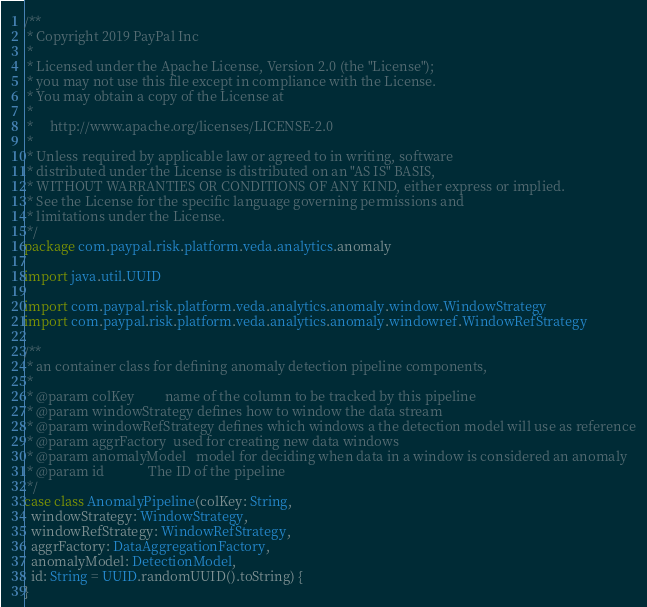Convert code to text. <code><loc_0><loc_0><loc_500><loc_500><_Scala_>/**
 * Copyright 2019 PayPal Inc
 *
 * Licensed under the Apache License, Version 2.0 (the "License");
 * you may not use this file except in compliance with the License.
 * You may obtain a copy of the License at
 *
 *     http://www.apache.org/licenses/LICENSE-2.0
 *
 * Unless required by applicable law or agreed to in writing, software
 * distributed under the License is distributed on an "AS IS" BASIS,
 * WITHOUT WARRANTIES OR CONDITIONS OF ANY KIND, either express or implied.
 * See the License for the specific language governing permissions and
 * limitations under the License.
 */
package com.paypal.risk.platform.veda.analytics.anomaly

import java.util.UUID

import com.paypal.risk.platform.veda.analytics.anomaly.window.WindowStrategy
import com.paypal.risk.platform.veda.analytics.anomaly.windowref.WindowRefStrategy

/**
 * an container class for defining anomaly detection pipeline components,
 *
 * @param colKey         name of the column to be tracked by this pipeline
 * @param windowStrategy defines how to window the data stream
 * @param windowRefStrategy defines which windows a the detection model will use as reference
 * @param aggrFactory  used for creating new data windows
 * @param anomalyModel   model for deciding when data in a window is considered an anomaly
 * @param id             The ID of the pipeline
 */
case class AnomalyPipeline(colKey: String,
  windowStrategy: WindowStrategy,
  windowRefStrategy: WindowRefStrategy,
  aggrFactory: DataAggregationFactory,
  anomalyModel: DetectionModel,
  id: String = UUID.randomUUID().toString) {
}
</code> 